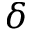Convert formula to latex. <formula><loc_0><loc_0><loc_500><loc_500>\delta</formula> 